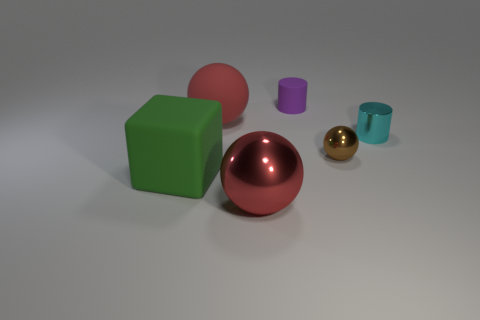There is another red thing that is the same size as the red rubber thing; what is its shape?
Your response must be concise. Sphere. How many other things are there of the same color as the big shiny ball?
Give a very brief answer. 1. The large ball that is behind the cube is what color?
Keep it short and to the point. Red. What number of other things are there of the same material as the small cyan cylinder
Your answer should be compact. 2. Are there more red metal things in front of the small sphere than small cyan objects left of the cyan metallic thing?
Your answer should be compact. Yes. There is a large metal ball; what number of brown metal things are behind it?
Your response must be concise. 1. Does the tiny brown ball have the same material as the large red sphere behind the green object?
Provide a short and direct response. No. Are there any other things that have the same shape as the green matte thing?
Provide a short and direct response. No. Is the material of the brown thing the same as the cyan cylinder?
Your response must be concise. Yes. There is a small brown ball to the right of the purple thing; is there a metal thing that is in front of it?
Offer a terse response. Yes. 